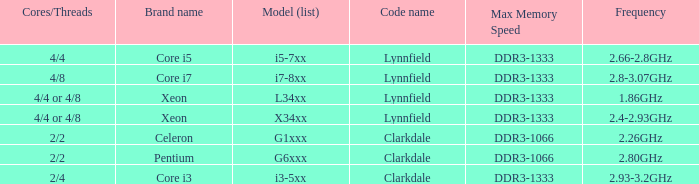List the number of cores for ddr3-1333 with frequencies between 2.66-2.8ghz. 4/4. 